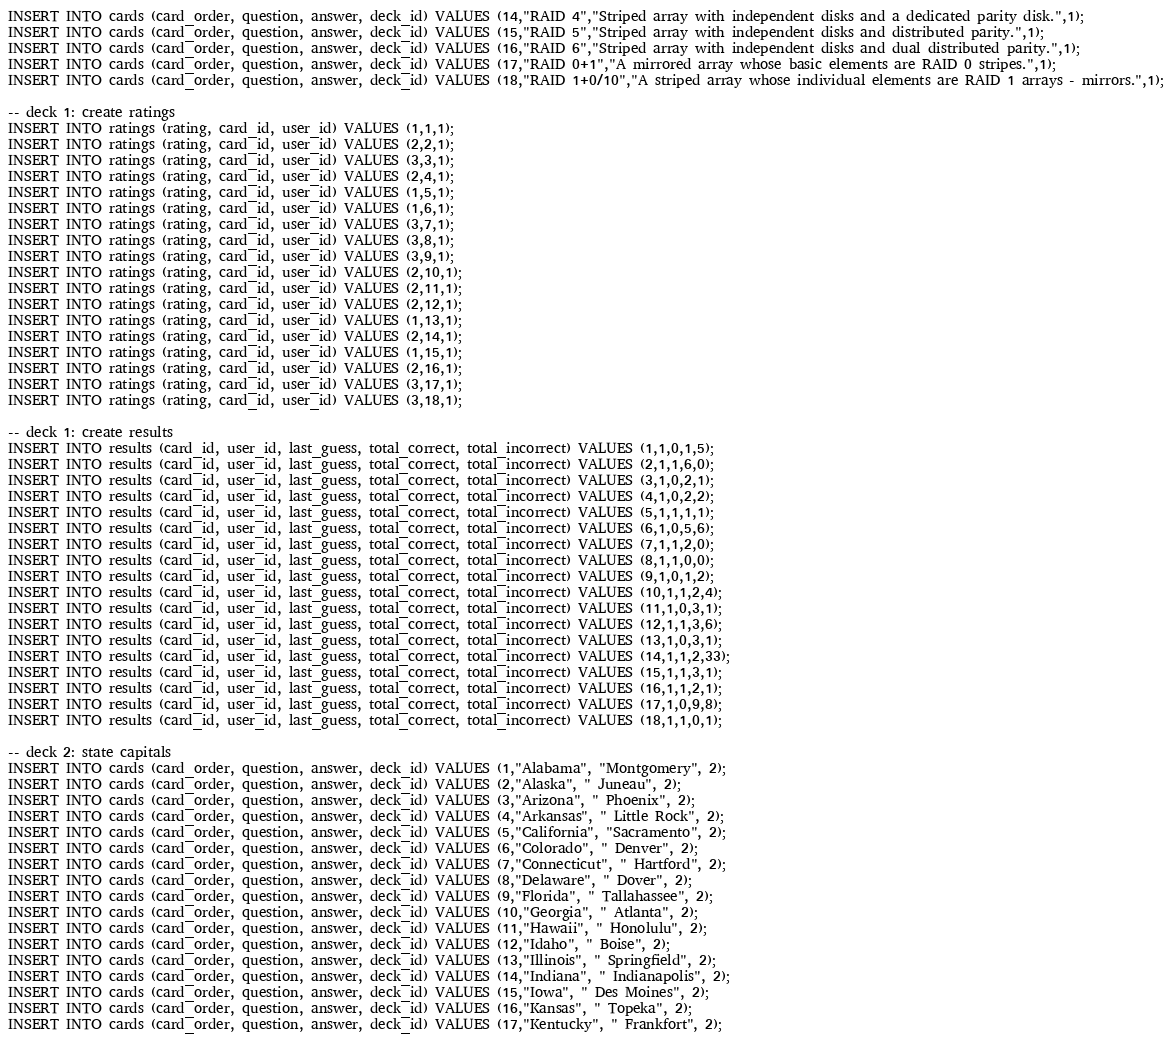<code> <loc_0><loc_0><loc_500><loc_500><_SQL_>INSERT INTO cards (card_order, question, answer, deck_id) VALUES (14,"RAID 4","Striped array with independent disks and a dedicated parity disk.",1);
INSERT INTO cards (card_order, question, answer, deck_id) VALUES (15,"RAID 5","Striped array with independent disks and distributed parity.",1);
INSERT INTO cards (card_order, question, answer, deck_id) VALUES (16,"RAID 6","Striped array with independent disks and dual distributed parity.",1);
INSERT INTO cards (card_order, question, answer, deck_id) VALUES (17,"RAID 0+1","A mirrored array whose basic elements are RAID 0 stripes.",1);
INSERT INTO cards (card_order, question, answer, deck_id) VALUES (18,"RAID 1+0/10","A striped array whose individual elements are RAID 1 arrays - mirrors.",1);

-- deck 1: create ratings
INSERT INTO ratings (rating, card_id, user_id) VALUES (1,1,1);
INSERT INTO ratings (rating, card_id, user_id) VALUES (2,2,1);
INSERT INTO ratings (rating, card_id, user_id) VALUES (3,3,1);
INSERT INTO ratings (rating, card_id, user_id) VALUES (2,4,1);
INSERT INTO ratings (rating, card_id, user_id) VALUES (1,5,1);
INSERT INTO ratings (rating, card_id, user_id) VALUES (1,6,1);
INSERT INTO ratings (rating, card_id, user_id) VALUES (3,7,1);
INSERT INTO ratings (rating, card_id, user_id) VALUES (3,8,1);
INSERT INTO ratings (rating, card_id, user_id) VALUES (3,9,1);
INSERT INTO ratings (rating, card_id, user_id) VALUES (2,10,1);
INSERT INTO ratings (rating, card_id, user_id) VALUES (2,11,1);
INSERT INTO ratings (rating, card_id, user_id) VALUES (2,12,1);
INSERT INTO ratings (rating, card_id, user_id) VALUES (1,13,1);
INSERT INTO ratings (rating, card_id, user_id) VALUES (2,14,1);
INSERT INTO ratings (rating, card_id, user_id) VALUES (1,15,1);
INSERT INTO ratings (rating, card_id, user_id) VALUES (2,16,1);
INSERT INTO ratings (rating, card_id, user_id) VALUES (3,17,1);
INSERT INTO ratings (rating, card_id, user_id) VALUES (3,18,1);

-- deck 1: create results
INSERT INTO results (card_id, user_id, last_guess, total_correct, total_incorrect) VALUES (1,1,0,1,5);
INSERT INTO results (card_id, user_id, last_guess, total_correct, total_incorrect) VALUES (2,1,1,6,0);
INSERT INTO results (card_id, user_id, last_guess, total_correct, total_incorrect) VALUES (3,1,0,2,1);
INSERT INTO results (card_id, user_id, last_guess, total_correct, total_incorrect) VALUES (4,1,0,2,2);
INSERT INTO results (card_id, user_id, last_guess, total_correct, total_incorrect) VALUES (5,1,1,1,1);
INSERT INTO results (card_id, user_id, last_guess, total_correct, total_incorrect) VALUES (6,1,0,5,6);
INSERT INTO results (card_id, user_id, last_guess, total_correct, total_incorrect) VALUES (7,1,1,2,0);
INSERT INTO results (card_id, user_id, last_guess, total_correct, total_incorrect) VALUES (8,1,1,0,0);
INSERT INTO results (card_id, user_id, last_guess, total_correct, total_incorrect) VALUES (9,1,0,1,2);
INSERT INTO results (card_id, user_id, last_guess, total_correct, total_incorrect) VALUES (10,1,1,2,4);
INSERT INTO results (card_id, user_id, last_guess, total_correct, total_incorrect) VALUES (11,1,0,3,1);
INSERT INTO results (card_id, user_id, last_guess, total_correct, total_incorrect) VALUES (12,1,1,3,6);
INSERT INTO results (card_id, user_id, last_guess, total_correct, total_incorrect) VALUES (13,1,0,3,1);
INSERT INTO results (card_id, user_id, last_guess, total_correct, total_incorrect) VALUES (14,1,1,2,33);
INSERT INTO results (card_id, user_id, last_guess, total_correct, total_incorrect) VALUES (15,1,1,3,1);
INSERT INTO results (card_id, user_id, last_guess, total_correct, total_incorrect) VALUES (16,1,1,2,1);
INSERT INTO results (card_id, user_id, last_guess, total_correct, total_incorrect) VALUES (17,1,0,9,8);
INSERT INTO results (card_id, user_id, last_guess, total_correct, total_incorrect) VALUES (18,1,1,0,1);

-- deck 2: state capitals
INSERT INTO cards (card_order, question, answer, deck_id) VALUES (1,"Alabama", "Montgomery", 2);
INSERT INTO cards (card_order, question, answer, deck_id) VALUES (2,"Alaska", " Juneau", 2);
INSERT INTO cards (card_order, question, answer, deck_id) VALUES (3,"Arizona", " Phoenix", 2);
INSERT INTO cards (card_order, question, answer, deck_id) VALUES (4,"Arkansas", " Little Rock", 2);
INSERT INTO cards (card_order, question, answer, deck_id) VALUES (5,"California", "Sacramento", 2);
INSERT INTO cards (card_order, question, answer, deck_id) VALUES (6,"Colorado", " Denver", 2);
INSERT INTO cards (card_order, question, answer, deck_id) VALUES (7,"Connecticut", " Hartford", 2);
INSERT INTO cards (card_order, question, answer, deck_id) VALUES (8,"Delaware", " Dover", 2);
INSERT INTO cards (card_order, question, answer, deck_id) VALUES (9,"Florida", " Tallahassee", 2);
INSERT INTO cards (card_order, question, answer, deck_id) VALUES (10,"Georgia", " Atlanta", 2);
INSERT INTO cards (card_order, question, answer, deck_id) VALUES (11,"Hawaii", " Honolulu", 2);
INSERT INTO cards (card_order, question, answer, deck_id) VALUES (12,"Idaho", " Boise", 2);
INSERT INTO cards (card_order, question, answer, deck_id) VALUES (13,"Illinois", " Springfield", 2);
INSERT INTO cards (card_order, question, answer, deck_id) VALUES (14,"Indiana", " Indianapolis", 2);
INSERT INTO cards (card_order, question, answer, deck_id) VALUES (15,"Iowa", " Des Moines", 2);
INSERT INTO cards (card_order, question, answer, deck_id) VALUES (16,"Kansas", " Topeka", 2);
INSERT INTO cards (card_order, question, answer, deck_id) VALUES (17,"Kentucky", " Frankfort", 2);</code> 